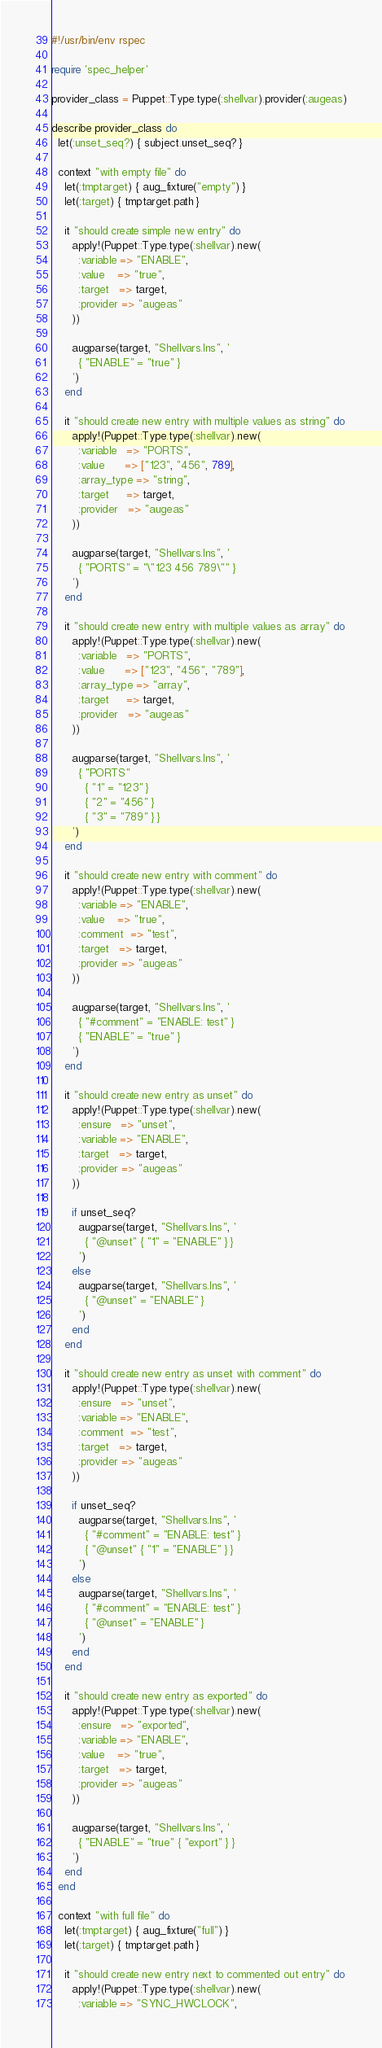<code> <loc_0><loc_0><loc_500><loc_500><_Ruby_>#!/usr/bin/env rspec

require 'spec_helper'

provider_class = Puppet::Type.type(:shellvar).provider(:augeas)

describe provider_class do
  let(:unset_seq?) { subject.unset_seq? }

  context "with empty file" do
    let(:tmptarget) { aug_fixture("empty") }
    let(:target) { tmptarget.path }

    it "should create simple new entry" do
      apply!(Puppet::Type.type(:shellvar).new(
        :variable => "ENABLE",
        :value    => "true",
        :target   => target,
        :provider => "augeas"
      ))

      augparse(target, "Shellvars.lns", '
        { "ENABLE" = "true" }
      ')
    end

    it "should create new entry with multiple values as string" do
      apply!(Puppet::Type.type(:shellvar).new(
        :variable   => "PORTS",
        :value      => ["123", "456", 789],
        :array_type => "string",
        :target     => target,
        :provider   => "augeas"
      ))

      augparse(target, "Shellvars.lns", '
        { "PORTS" = "\"123 456 789\"" }
      ')
    end

    it "should create new entry with multiple values as array" do
      apply!(Puppet::Type.type(:shellvar).new(
        :variable   => "PORTS",
        :value      => ["123", "456", "789"],
        :array_type => "array",
        :target     => target,
        :provider   => "augeas"
      ))

      augparse(target, "Shellvars.lns", '
        { "PORTS"
          { "1" = "123" }
          { "2" = "456" }
          { "3" = "789" } }
      ')
    end

    it "should create new entry with comment" do
      apply!(Puppet::Type.type(:shellvar).new(
        :variable => "ENABLE",
        :value    => "true",
        :comment  => "test",
        :target   => target,
        :provider => "augeas"
      ))

      augparse(target, "Shellvars.lns", '
        { "#comment" = "ENABLE: test" }
        { "ENABLE" = "true" }
      ')
    end

    it "should create new entry as unset" do
      apply!(Puppet::Type.type(:shellvar).new(
        :ensure   => "unset",
        :variable => "ENABLE",
        :target   => target,
        :provider => "augeas"
      ))

      if unset_seq?
        augparse(target, "Shellvars.lns", '
          { "@unset" { "1" = "ENABLE" } }
        ')
      else
        augparse(target, "Shellvars.lns", '
          { "@unset" = "ENABLE" }
        ')
      end
    end

    it "should create new entry as unset with comment" do
      apply!(Puppet::Type.type(:shellvar).new(
        :ensure   => "unset",
        :variable => "ENABLE",
        :comment  => "test",
        :target   => target,
        :provider => "augeas"
      ))

      if unset_seq?
        augparse(target, "Shellvars.lns", '
          { "#comment" = "ENABLE: test" }
          { "@unset" { "1" = "ENABLE" } }
        ')
      else
        augparse(target, "Shellvars.lns", '
          { "#comment" = "ENABLE: test" }
          { "@unset" = "ENABLE" }
        ')
      end
    end

    it "should create new entry as exported" do
      apply!(Puppet::Type.type(:shellvar).new(
        :ensure   => "exported",
        :variable => "ENABLE",
        :value    => "true",
        :target   => target,
        :provider => "augeas"
      ))

      augparse(target, "Shellvars.lns", '
        { "ENABLE" = "true" { "export" } }
      ')
    end
  end

  context "with full file" do
    let(:tmptarget) { aug_fixture("full") }
    let(:target) { tmptarget.path }

    it "should create new entry next to commented out entry" do
      apply!(Puppet::Type.type(:shellvar).new(
        :variable => "SYNC_HWCLOCK",</code> 